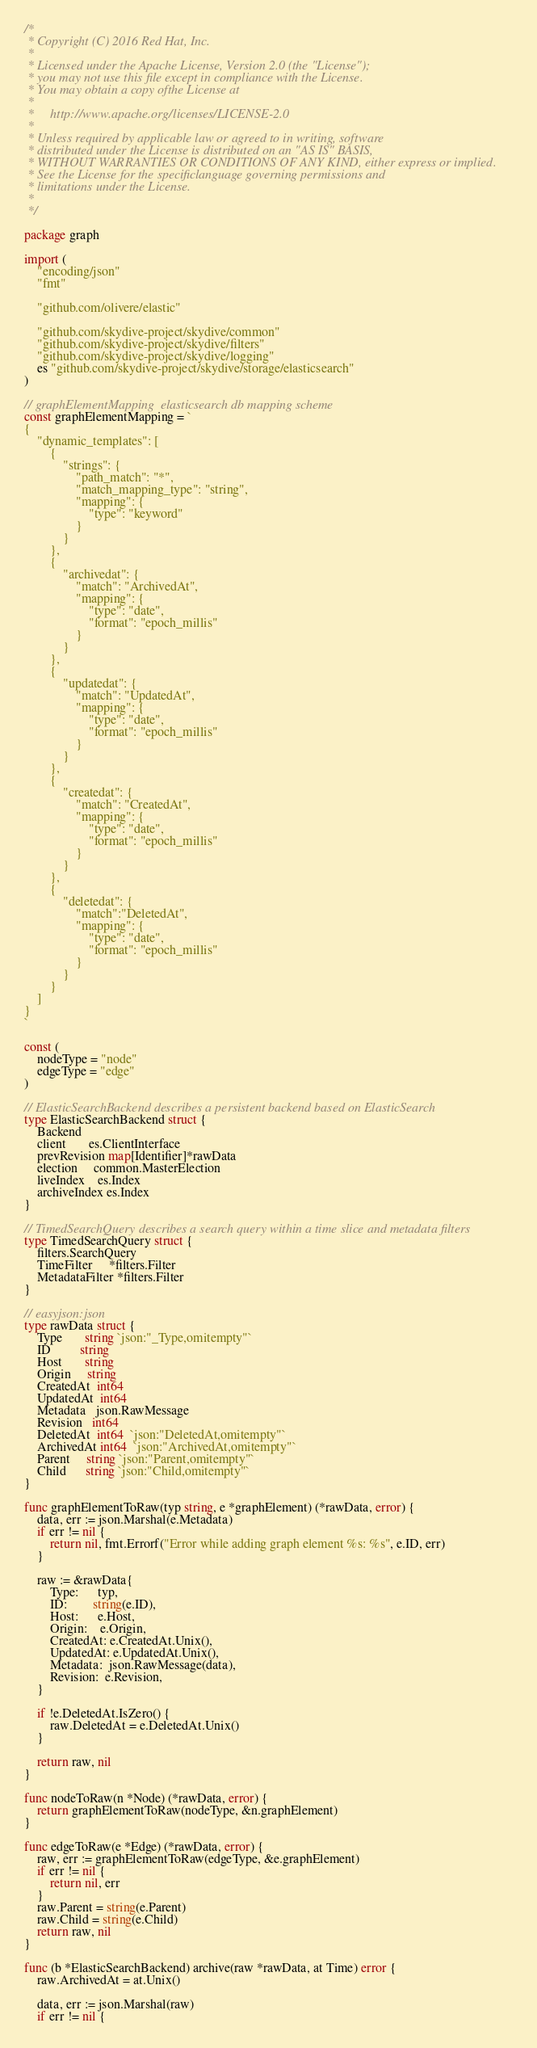<code> <loc_0><loc_0><loc_500><loc_500><_Go_>/*
 * Copyright (C) 2016 Red Hat, Inc.
 *
 * Licensed under the Apache License, Version 2.0 (the "License");
 * you may not use this file except in compliance with the License.
 * You may obtain a copy ofthe License at
 *
 *     http://www.apache.org/licenses/LICENSE-2.0
 *
 * Unless required by applicable law or agreed to in writing, software
 * distributed under the License is distributed on an "AS IS" BASIS,
 * WITHOUT WARRANTIES OR CONDITIONS OF ANY KIND, either express or implied.
 * See the License for the specificlanguage governing permissions and
 * limitations under the License.
 *
 */

package graph

import (
	"encoding/json"
	"fmt"

	"github.com/olivere/elastic"

	"github.com/skydive-project/skydive/common"
	"github.com/skydive-project/skydive/filters"
	"github.com/skydive-project/skydive/logging"
	es "github.com/skydive-project/skydive/storage/elasticsearch"
)

// graphElementMapping  elasticsearch db mapping scheme
const graphElementMapping = `
{
	"dynamic_templates": [
		{
			"strings": {
				"path_match": "*",
				"match_mapping_type": "string",
				"mapping": {
					"type": "keyword"
				}
			}
		},
		{
			"archivedat": {
				"match": "ArchivedAt",
				"mapping": {
					"type": "date",
					"format": "epoch_millis"
				}
			}
		},
		{
			"updatedat": {
				"match": "UpdatedAt",
				"mapping": {
					"type": "date",
					"format": "epoch_millis"
				}
			}
		},
		{
			"createdat": {
				"match": "CreatedAt",
				"mapping": {
					"type": "date",
					"format": "epoch_millis"
				}
			}
		},
		{
			"deletedat": {
				"match":"DeletedAt",
				"mapping": {
					"type": "date",
					"format": "epoch_millis"
				}
			}
		}
	]
}
`

const (
	nodeType = "node"
	edgeType = "edge"
)

// ElasticSearchBackend describes a persistent backend based on ElasticSearch
type ElasticSearchBackend struct {
	Backend
	client       es.ClientInterface
	prevRevision map[Identifier]*rawData
	election     common.MasterElection
	liveIndex    es.Index
	archiveIndex es.Index
}

// TimedSearchQuery describes a search query within a time slice and metadata filters
type TimedSearchQuery struct {
	filters.SearchQuery
	TimeFilter     *filters.Filter
	MetadataFilter *filters.Filter
}

// easyjson:json
type rawData struct {
	Type       string `json:"_Type,omitempty"`
	ID         string
	Host       string
	Origin     string
	CreatedAt  int64
	UpdatedAt  int64
	Metadata   json.RawMessage
	Revision   int64
	DeletedAt  int64  `json:"DeletedAt,omitempty"`
	ArchivedAt int64  `json:"ArchivedAt,omitempty"`
	Parent     string `json:"Parent,omitempty"`
	Child      string `json:"Child,omitempty"`
}

func graphElementToRaw(typ string, e *graphElement) (*rawData, error) {
	data, err := json.Marshal(e.Metadata)
	if err != nil {
		return nil, fmt.Errorf("Error while adding graph element %s: %s", e.ID, err)
	}

	raw := &rawData{
		Type:      typ,
		ID:        string(e.ID),
		Host:      e.Host,
		Origin:    e.Origin,
		CreatedAt: e.CreatedAt.Unix(),
		UpdatedAt: e.UpdatedAt.Unix(),
		Metadata:  json.RawMessage(data),
		Revision:  e.Revision,
	}

	if !e.DeletedAt.IsZero() {
		raw.DeletedAt = e.DeletedAt.Unix()
	}

	return raw, nil
}

func nodeToRaw(n *Node) (*rawData, error) {
	return graphElementToRaw(nodeType, &n.graphElement)
}

func edgeToRaw(e *Edge) (*rawData, error) {
	raw, err := graphElementToRaw(edgeType, &e.graphElement)
	if err != nil {
		return nil, err
	}
	raw.Parent = string(e.Parent)
	raw.Child = string(e.Child)
	return raw, nil
}

func (b *ElasticSearchBackend) archive(raw *rawData, at Time) error {
	raw.ArchivedAt = at.Unix()

	data, err := json.Marshal(raw)
	if err != nil {</code> 